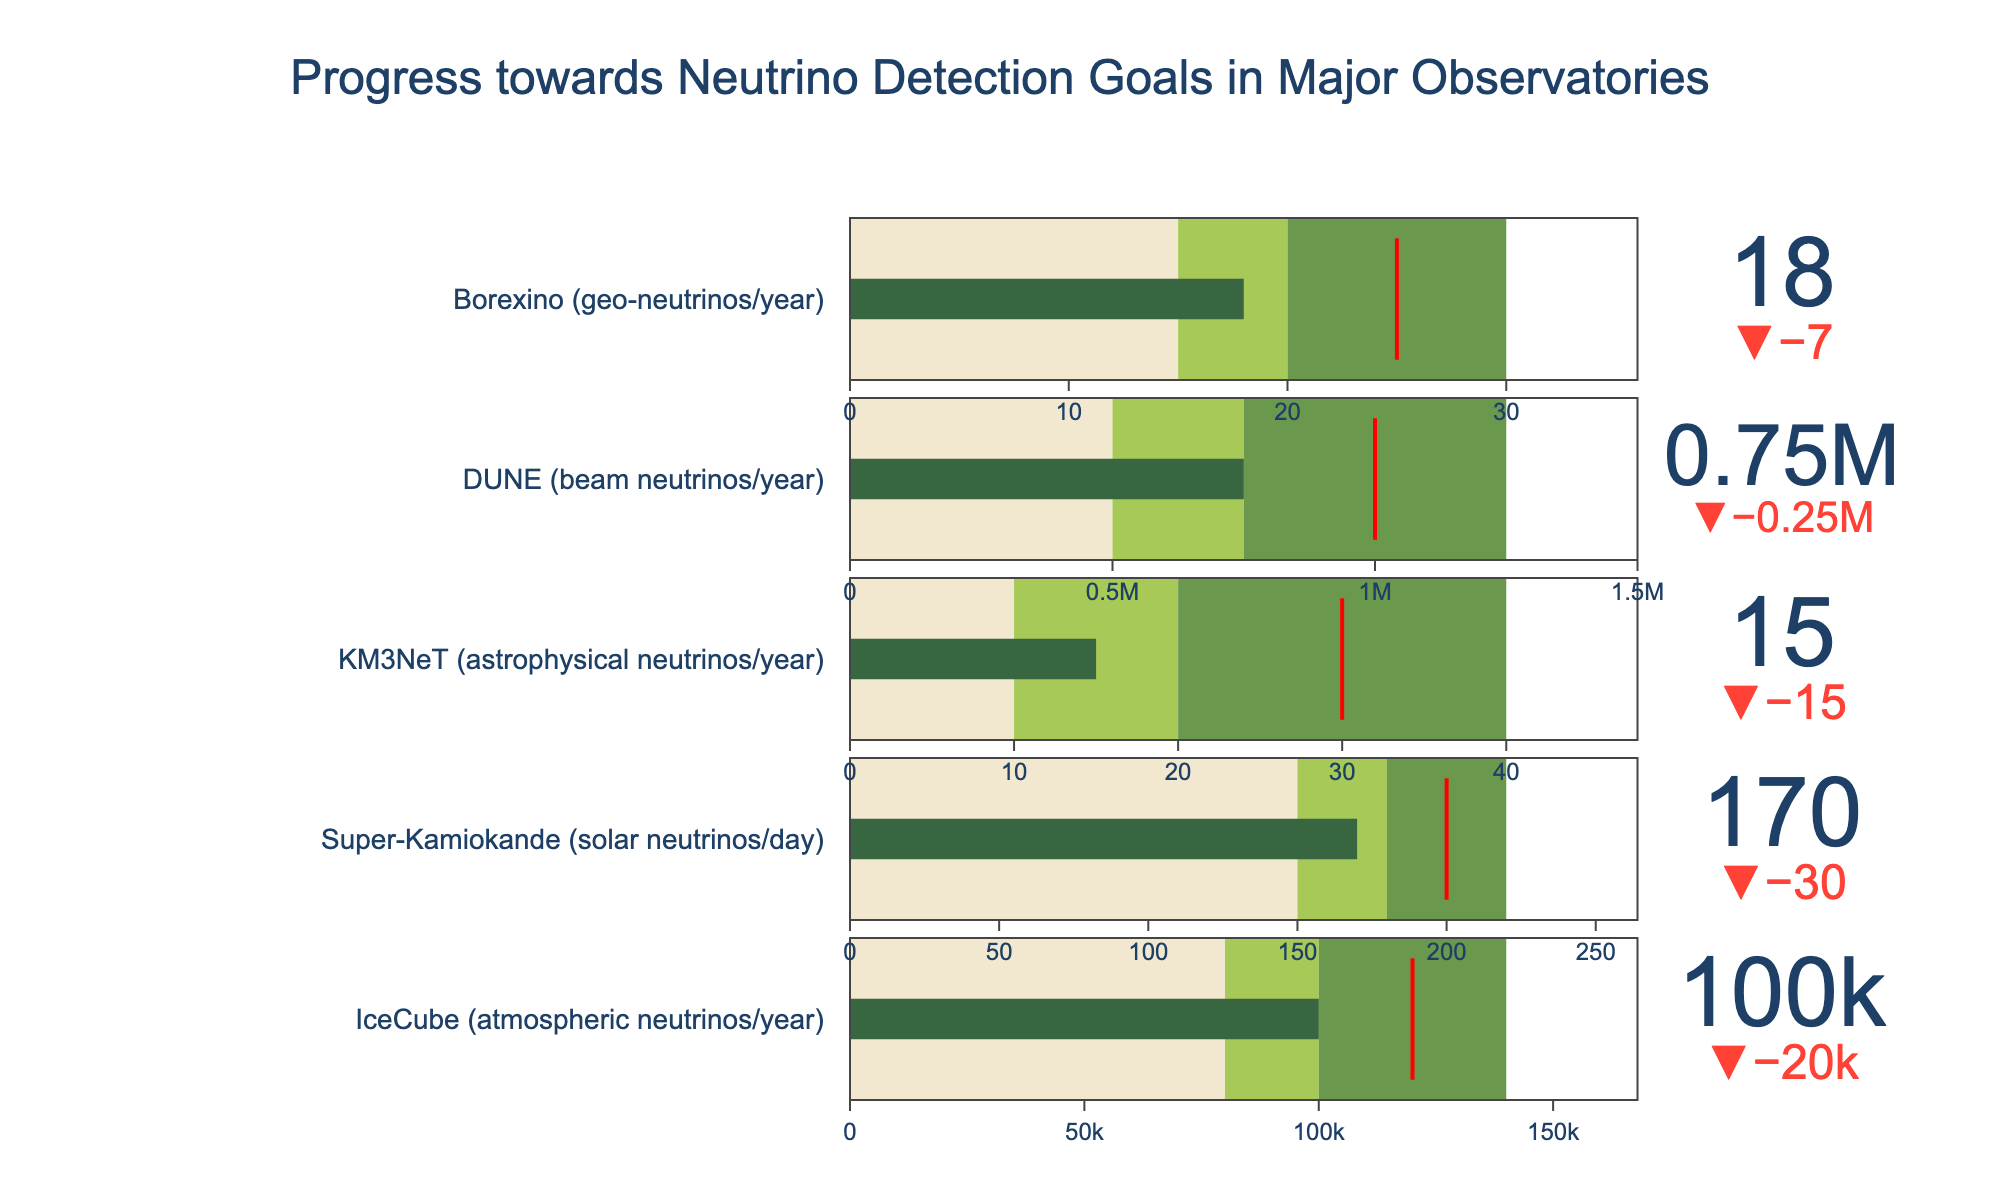Which observatory has the highest actual neutrino detection count? From the chart, the observatory with the highest value on the bullet chart indicates the highest actual neutrino count. This is seen to be the DUNE observatory with a count of 750,000 beam neutrinos per year.
Answer: DUNE Is IceCube meeting its target for atmospheric neutrino detection? IceCube's actual value of 100,000 is below the target of 120,000, as indicated by the delta marker showing a shortfall.
Answer: No How many observatories have actual values in the mid-threshold range? Observing each bullet chart, IceCube, Super-Kamiokande, and Borexino have actual values within their respective mid-threshold ranges (100,000, 170, and 18).
Answer: 3 What is the range of the high-threshold for KM3NeT? From the bullet chart, KM3NeT's high-threshold range is illustrated by the color change and marked as 40 for the upper limit.
Answer: 40 Which observatory is furthest from reaching its target? KM3NeT's actual value is 15 against a target of 30, revealing a shortfall ratio of 50%, which is greater than other observatories' shortfall ratios.
Answer: KM3NeT Compare the actual neutrino detection of IceCube with its mid-threshold value. Is it meeting or surpassing it? IceCube's actual value of 100,000 meets its mid-threshold value precisely, as shown on the chart.
Answer: Meeting What can you infer about Borexino's performance relative to its high-threshold? Borexino's actual detection count is 18, while its high-threshold is 30, putting Borexino far below the high-threshold.
Answer: Below How much more is needed for Super-Kamiokande to reach its target in terms of solar neutrinos per day? Super-Kamiokande's actual detection count is 170 per day and its target is 200, so 200 - 170 is 30 solar neutrinos per day needed to reach the target.
Answer: 30 Which observatory's actual detection is closest to its target? By the delta indicators on the chart, DUNE's actual value of 750,000 is closest to its target of 1,000,000, having the smallest relative shortfall.
Answer: DUNE Does any observatory's actual detection exceed their high-threshold? None of the specified observatories have actual values that exceed their high-thresholds as evidenced by the green levels in the bullet charts.
Answer: No 